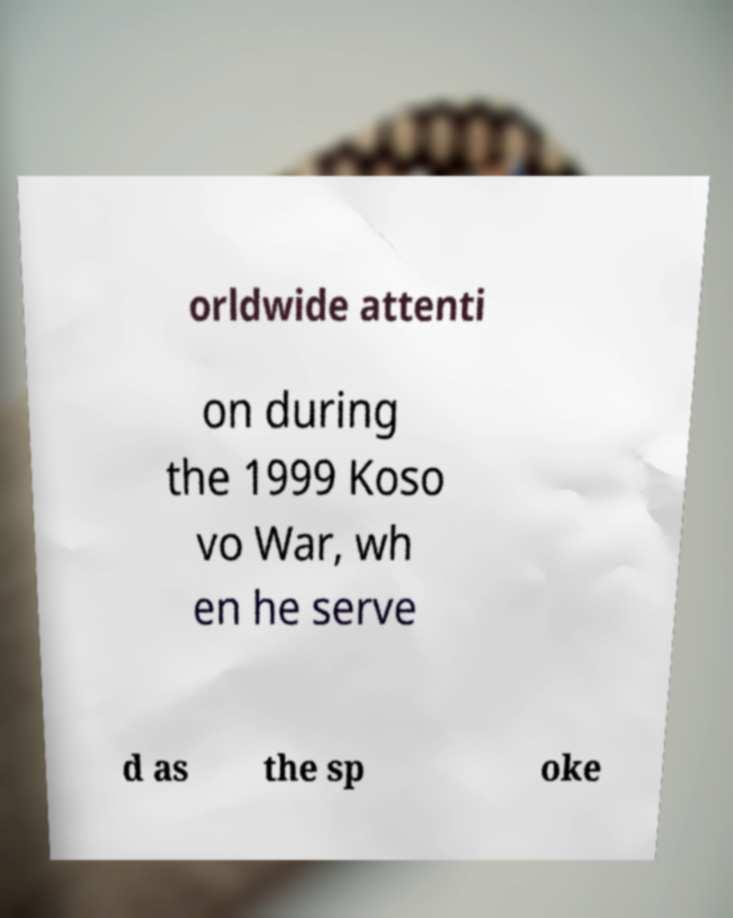Can you read and provide the text displayed in the image?This photo seems to have some interesting text. Can you extract and type it out for me? orldwide attenti on during the 1999 Koso vo War, wh en he serve d as the sp oke 